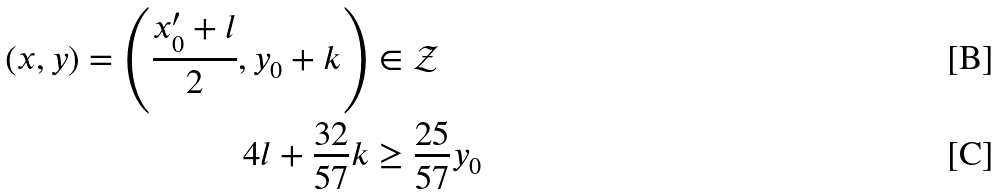<formula> <loc_0><loc_0><loc_500><loc_500>( x , y ) = \left ( \frac { x ^ { \prime } _ { 0 } + l } { 2 } , y _ { 0 } + k \right ) & \in \mathcal { Z } \\ 4 l + \frac { 3 2 } { 5 7 } k & \geq \frac { 2 5 } { 5 7 } y _ { 0 }</formula> 